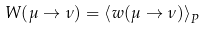<formula> <loc_0><loc_0><loc_500><loc_500>W ( \mu \to \nu ) = \left \langle w ( \mu \to \nu ) \right \rangle _ { P }</formula> 